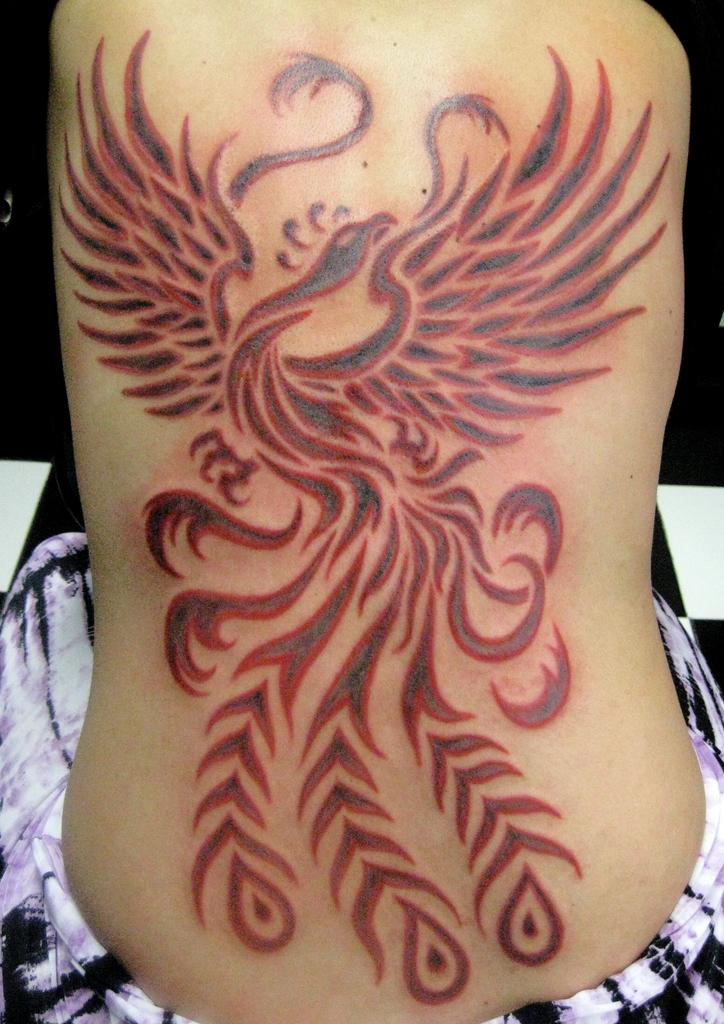What is depicted on a human body in the image? There is a tattoo on a human body in the image. How many friends are sitting on the bed in the image? There is no mention of friends or a bed in the image; it only features a tattoo on a human body. 